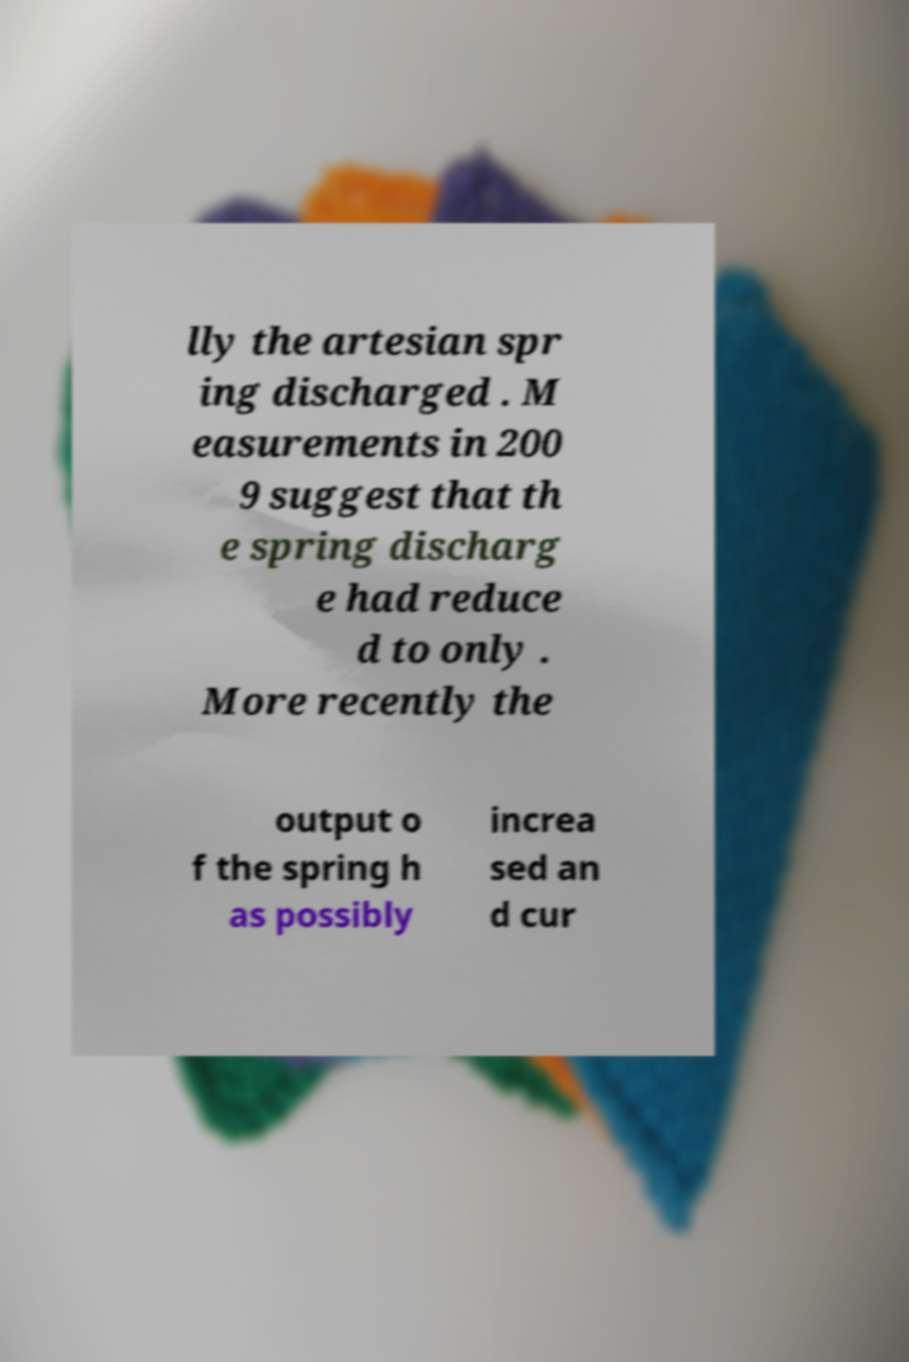For documentation purposes, I need the text within this image transcribed. Could you provide that? lly the artesian spr ing discharged . M easurements in 200 9 suggest that th e spring discharg e had reduce d to only . More recently the output o f the spring h as possibly increa sed an d cur 